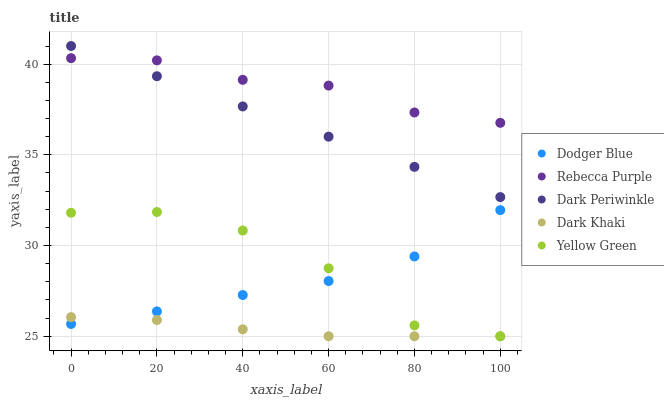Does Dark Khaki have the minimum area under the curve?
Answer yes or no. Yes. Does Rebecca Purple have the maximum area under the curve?
Answer yes or no. Yes. Does Yellow Green have the minimum area under the curve?
Answer yes or no. No. Does Yellow Green have the maximum area under the curve?
Answer yes or no. No. Is Dark Periwinkle the smoothest?
Answer yes or no. Yes. Is Yellow Green the roughest?
Answer yes or no. Yes. Is Dodger Blue the smoothest?
Answer yes or no. No. Is Dodger Blue the roughest?
Answer yes or no. No. Does Dark Khaki have the lowest value?
Answer yes or no. Yes. Does Dodger Blue have the lowest value?
Answer yes or no. No. Does Dark Periwinkle have the highest value?
Answer yes or no. Yes. Does Yellow Green have the highest value?
Answer yes or no. No. Is Dodger Blue less than Rebecca Purple?
Answer yes or no. Yes. Is Rebecca Purple greater than Dark Khaki?
Answer yes or no. Yes. Does Yellow Green intersect Dark Khaki?
Answer yes or no. Yes. Is Yellow Green less than Dark Khaki?
Answer yes or no. No. Is Yellow Green greater than Dark Khaki?
Answer yes or no. No. Does Dodger Blue intersect Rebecca Purple?
Answer yes or no. No. 